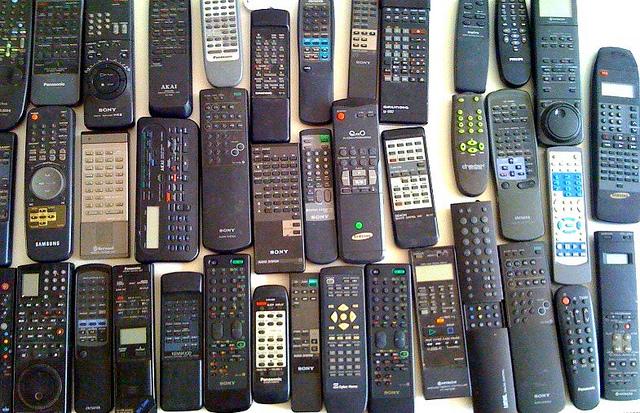Are these cell phones?
Concise answer only. No. Are all the gadgets remotes?
Short answer required. Yes. Are there any remotes that aren't black?
Answer briefly. Yes. 